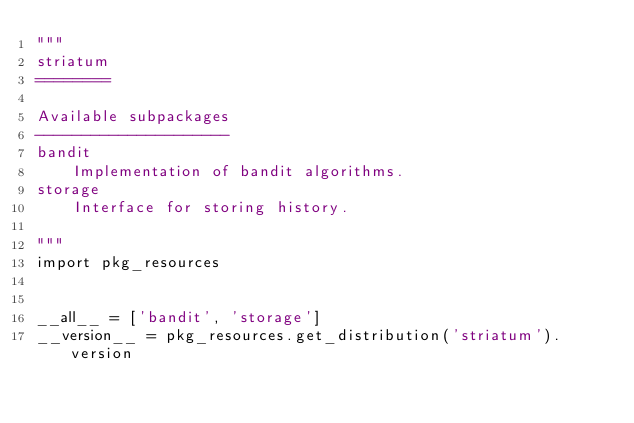<code> <loc_0><loc_0><loc_500><loc_500><_Python_>"""
striatum
========

Available subpackages
---------------------
bandit
    Implementation of bandit algorithms.
storage
    Interface for storing history.

"""
import pkg_resources


__all__ = ['bandit', 'storage']
__version__ = pkg_resources.get_distribution('striatum').version
</code> 